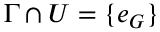<formula> <loc_0><loc_0><loc_500><loc_500>\Gamma \cap U = \{ e _ { G } \}</formula> 